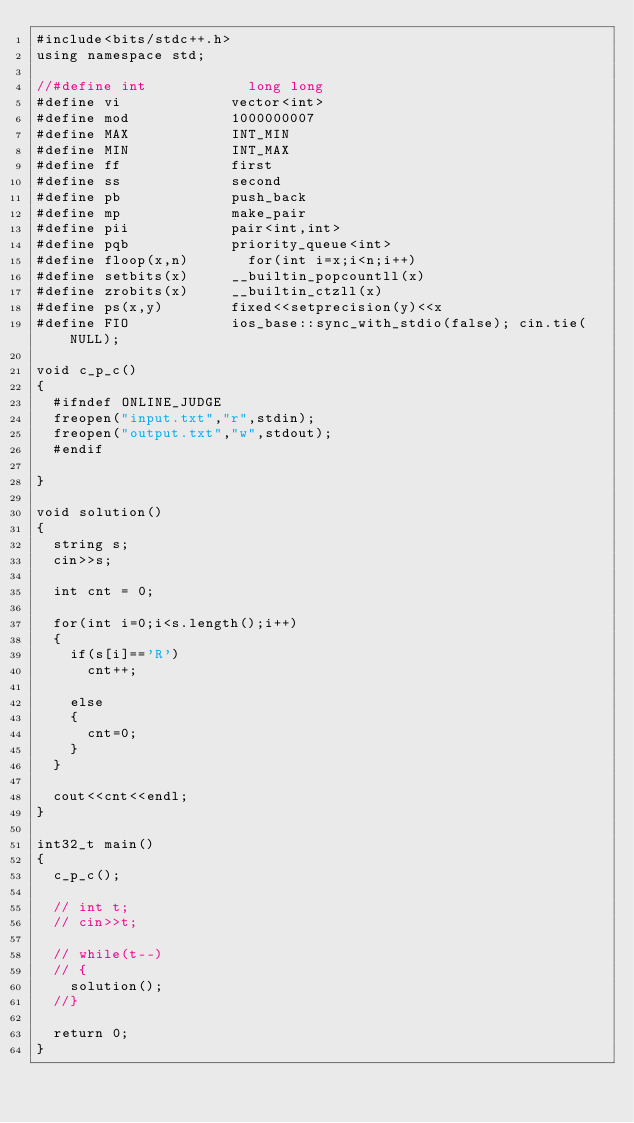<code> <loc_0><loc_0><loc_500><loc_500><_C++_>#include<bits/stdc++.h>
using namespace std;

//#define int            long long 
#define vi             vector<int>
#define mod            1000000007
#define MAX            INT_MIN
#define MIN            INT_MAX
#define ff             first
#define ss             second
#define pb             push_back
#define mp             make_pair
#define pii            pair<int,int>
#define pqb            priority_queue<int>
#define floop(x,n)       for(int i=x;i<n;i++)
#define setbits(x)     __builtin_popcountll(x)
#define zrobits(x)     __builtin_ctzll(x)
#define ps(x,y)        fixed<<setprecision(y)<<x         
#define FIO            ios_base::sync_with_stdio(false); cin.tie(NULL);
                  
void c_p_c()
{
	#ifndef ONLINE_JUDGE
	freopen("input.txt","r",stdin);
	freopen("output.txt","w",stdout);
	#endif   

}

void solution()
{
	string s;
	cin>>s;

	int cnt = 0;

	for(int i=0;i<s.length();i++)
	{
		if(s[i]=='R')
			cnt++;

		else
		{
			cnt=0;
		}
	}

	cout<<cnt<<endl;
}

int32_t main()
{
	c_p_c();

	// int t;
	// cin>>t;

	// while(t--)
	// {
		solution();
	//}

	return 0;
}
</code> 